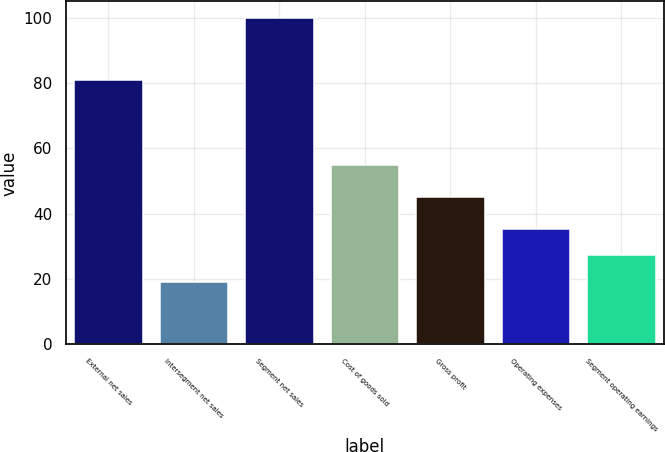<chart> <loc_0><loc_0><loc_500><loc_500><bar_chart><fcel>External net sales<fcel>Intersegment net sales<fcel>Segment net sales<fcel>Cost of goods sold<fcel>Gross profit<fcel>Operating expenses<fcel>Segment operating earnings<nl><fcel>80.9<fcel>19.1<fcel>100<fcel>54.8<fcel>45.2<fcel>35.28<fcel>27.19<nl></chart> 